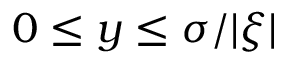<formula> <loc_0><loc_0><loc_500><loc_500>0 \leq y \leq \sigma / | \xi |</formula> 